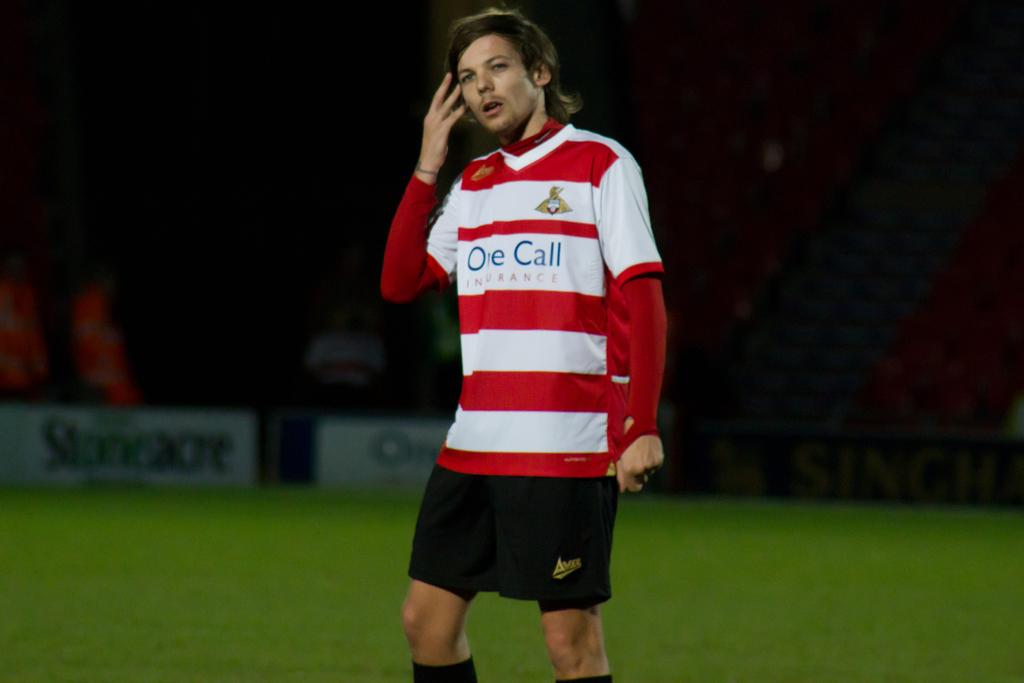What is written on the front of his jersey?
Your answer should be compact. One call. 